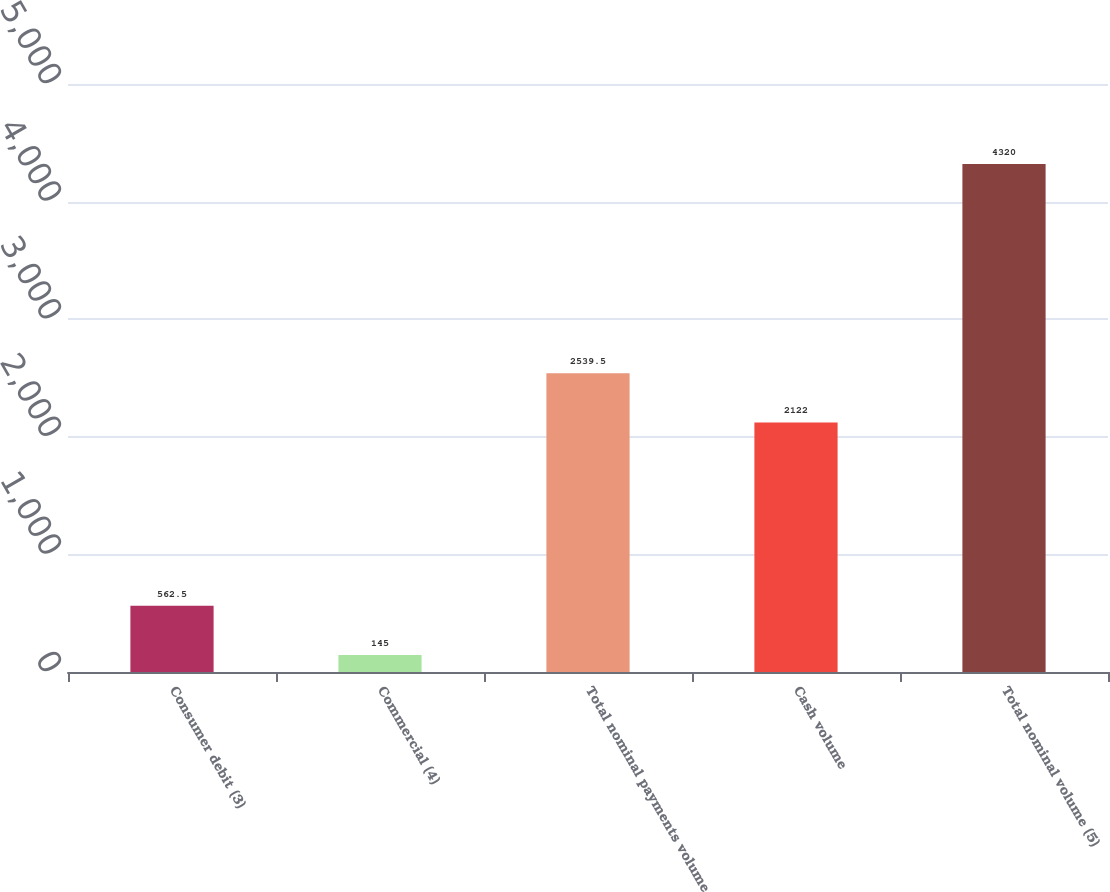<chart> <loc_0><loc_0><loc_500><loc_500><bar_chart><fcel>Consumer debit (3)<fcel>Commercial (4)<fcel>Total nominal payments volume<fcel>Cash volume<fcel>Total nominal volume (5)<nl><fcel>562.5<fcel>145<fcel>2539.5<fcel>2122<fcel>4320<nl></chart> 